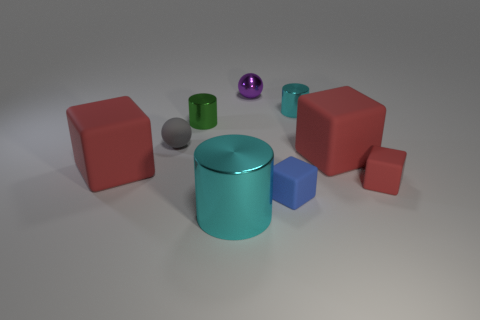What color is the large metallic cylinder?
Keep it short and to the point. Cyan. There is another thing that is the same color as the big shiny object; what is it made of?
Your answer should be compact. Metal. There is a shiny sphere; is its color the same as the matte thing left of the small gray matte object?
Provide a short and direct response. No. What number of other things are there of the same color as the big metal cylinder?
Provide a succinct answer. 1. What is the size of the cyan metal object behind the cyan thing in front of the big block that is right of the small blue rubber thing?
Offer a terse response. Small. There is a tiny rubber ball; are there any tiny metallic objects on the left side of it?
Offer a terse response. No. There is a purple metallic thing; is it the same size as the cyan shiny object in front of the gray matte thing?
Keep it short and to the point. No. What number of other things are there of the same material as the blue thing
Your answer should be very brief. 4. There is a thing that is both left of the small blue block and behind the green metal thing; what is its shape?
Ensure brevity in your answer.  Sphere. Is the size of the block that is to the left of the tiny rubber sphere the same as the sphere that is to the right of the large metallic thing?
Your answer should be very brief. No. 